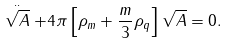<formula> <loc_0><loc_0><loc_500><loc_500>\stackrel { . . } { \sqrt { A } } + 4 \pi \left [ \rho _ { m } + \frac { m } { 3 } \rho _ { q } \right ] \sqrt { A } = 0 .</formula> 